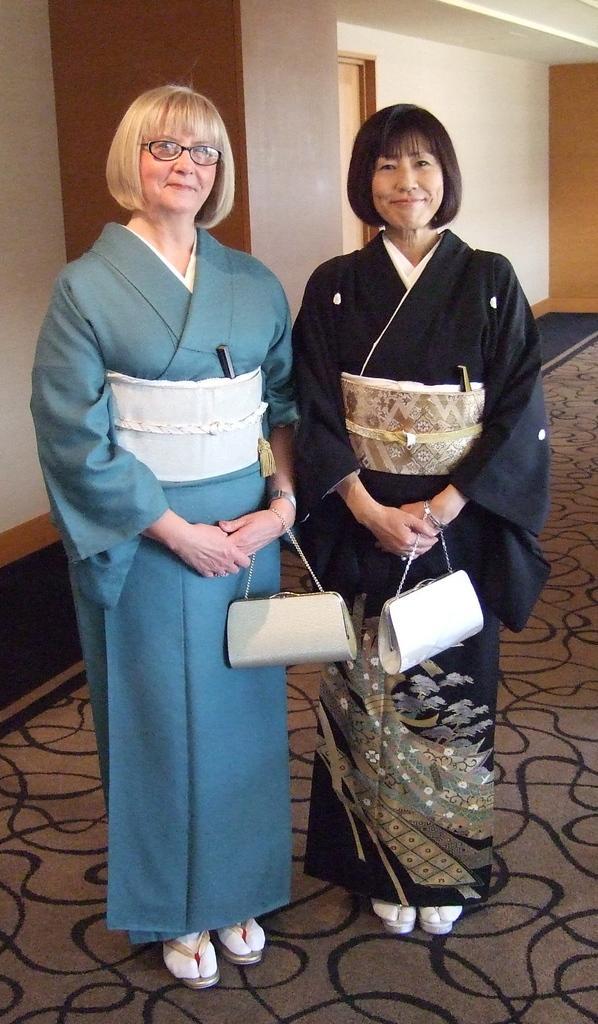Describe this image in one or two sentences. In this picture there to woman standing and smiling and they have to handbags in the backdrop there is a wall and is a door 